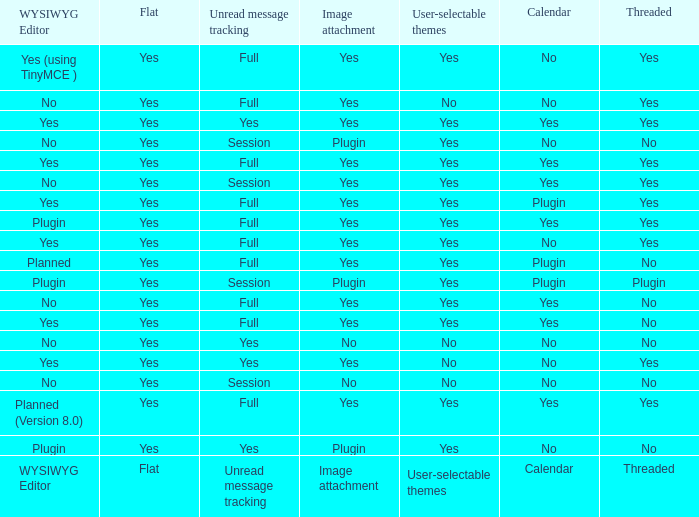Which Calendar has a WYSIWYG Editor of no, and an Unread message tracking of session, and an Image attachment of no? No. 